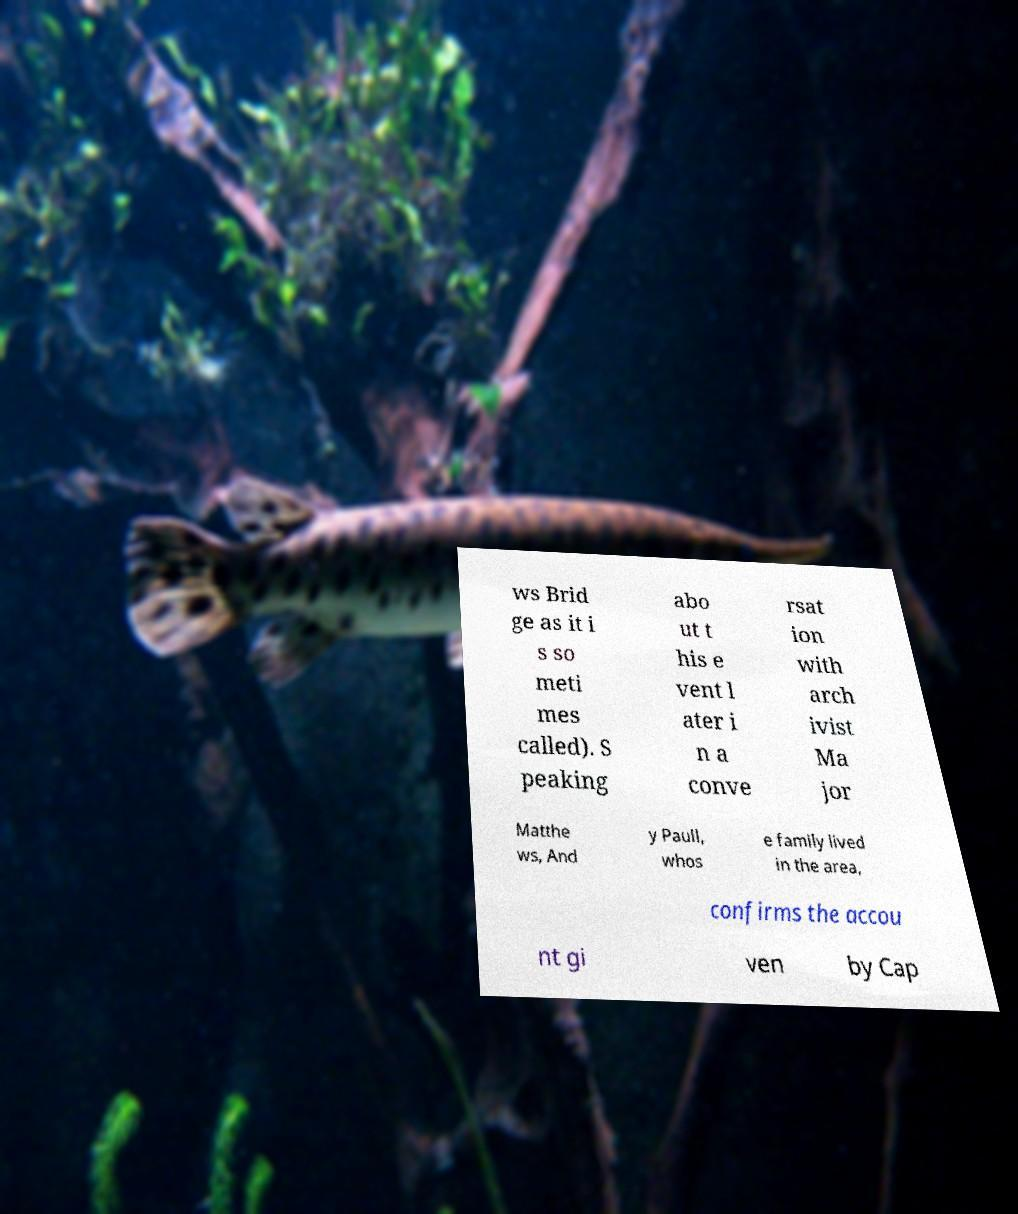What messages or text are displayed in this image? I need them in a readable, typed format. ws Brid ge as it i s so meti mes called). S peaking abo ut t his e vent l ater i n a conve rsat ion with arch ivist Ma jor Matthe ws, And y Paull, whos e family lived in the area, confirms the accou nt gi ven by Cap 